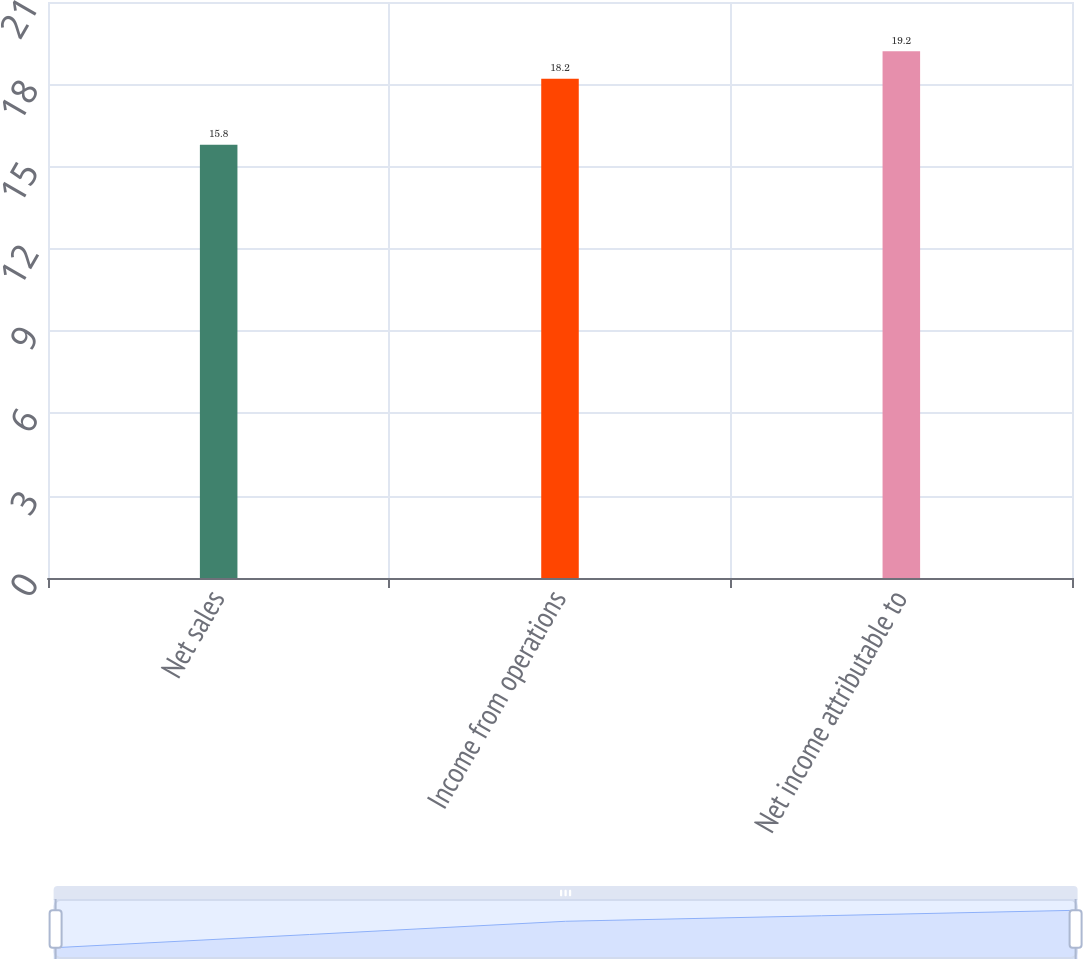Convert chart to OTSL. <chart><loc_0><loc_0><loc_500><loc_500><bar_chart><fcel>Net sales<fcel>Income from operations<fcel>Net income attributable to<nl><fcel>15.8<fcel>18.2<fcel>19.2<nl></chart> 